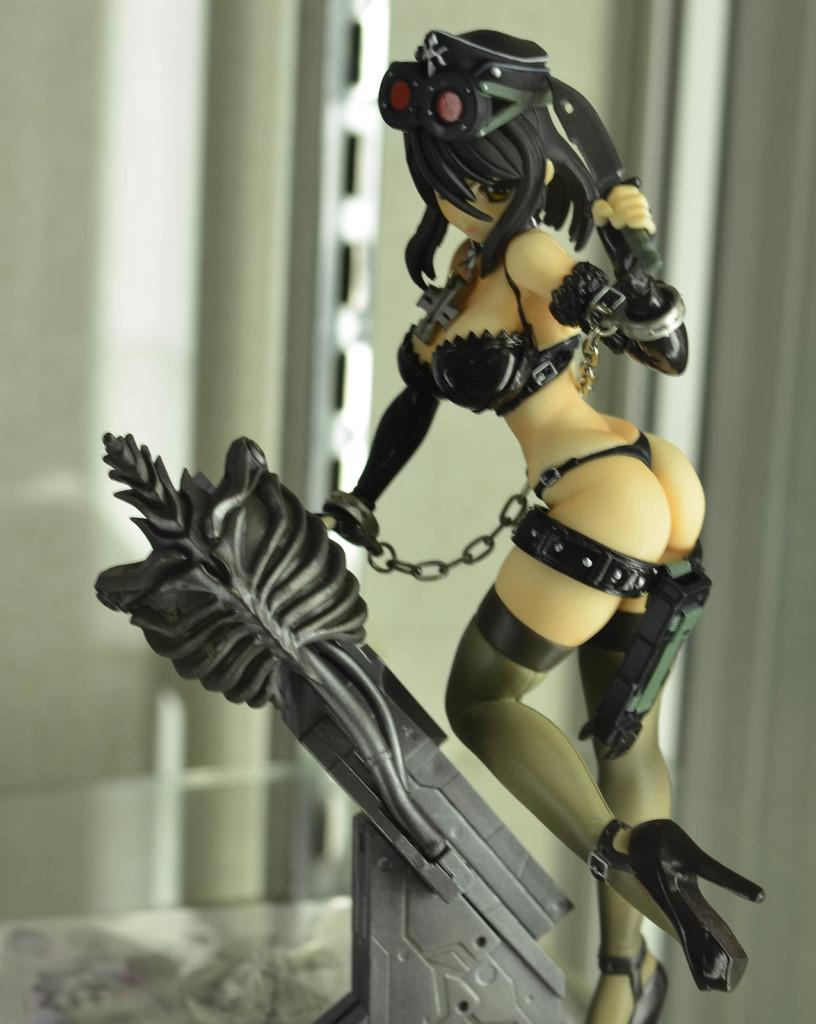What is the main subject of the image? There is a statue of a woman in the image. What is the woman wearing in the image? The woman is wearing a black dress and black footwear. What can be seen in the background of the image? There are white colored objects in the background of the image. What type of heart condition does the woman's sister have, as depicted in the image? There is no mention of a sister or any heart condition in the image. The image only features a statue of a woman wearing a black dress and black footwear, with white colored objects in the background. 